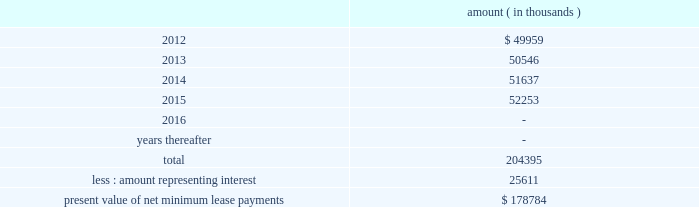Entergy corporation and subsidiaries notes to financial statements ferc audit report , system energy initially recorded as a net regulatory asset the difference between the recovery of the lease payments and the amounts expensed for interest and depreciation and continues to record this difference as a regulatory asset or liability on an ongoing basis , resulting in a zero net balance for the regulatory asset at the end of the lease term .
The amount was a net regulatory asset ( liability ) of ( $ 2.0 ) million and $ 60.6 million as of december 31 , 2011 and 2010 , respectively .
As of december 31 , 2011 , system energy had future minimum lease payments ( reflecting an implicit rate of 5.13% ( 5.13 % ) ) , which are recorded as long-term debt as follows : amount ( in thousands ) .

As of december 31 , 2011what was the percent of system energy future minimum lease payments that was due in 2015? 
Computations: (52253 / 204395)
Answer: 0.25565. 